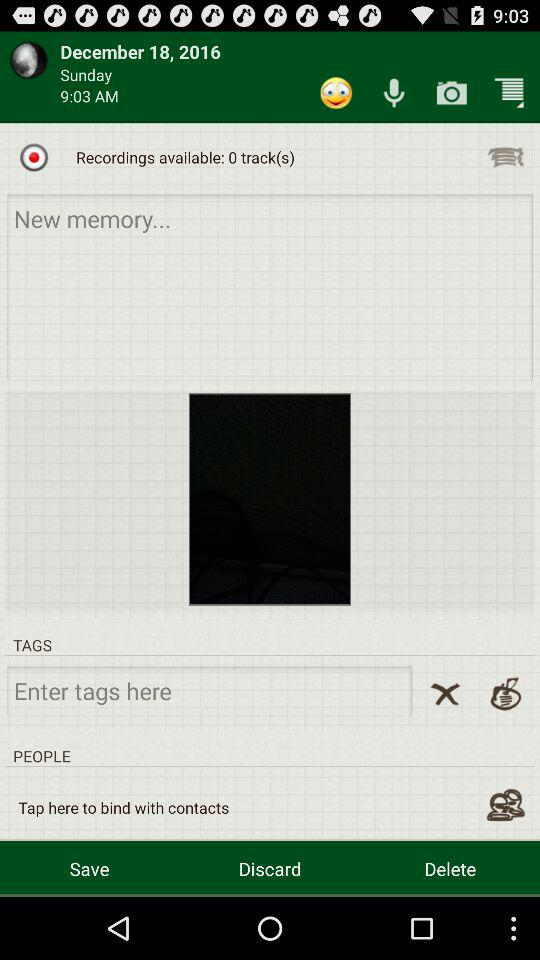How many "Recordings" tracks are available? There are 0 "Recordings" tracks available. 